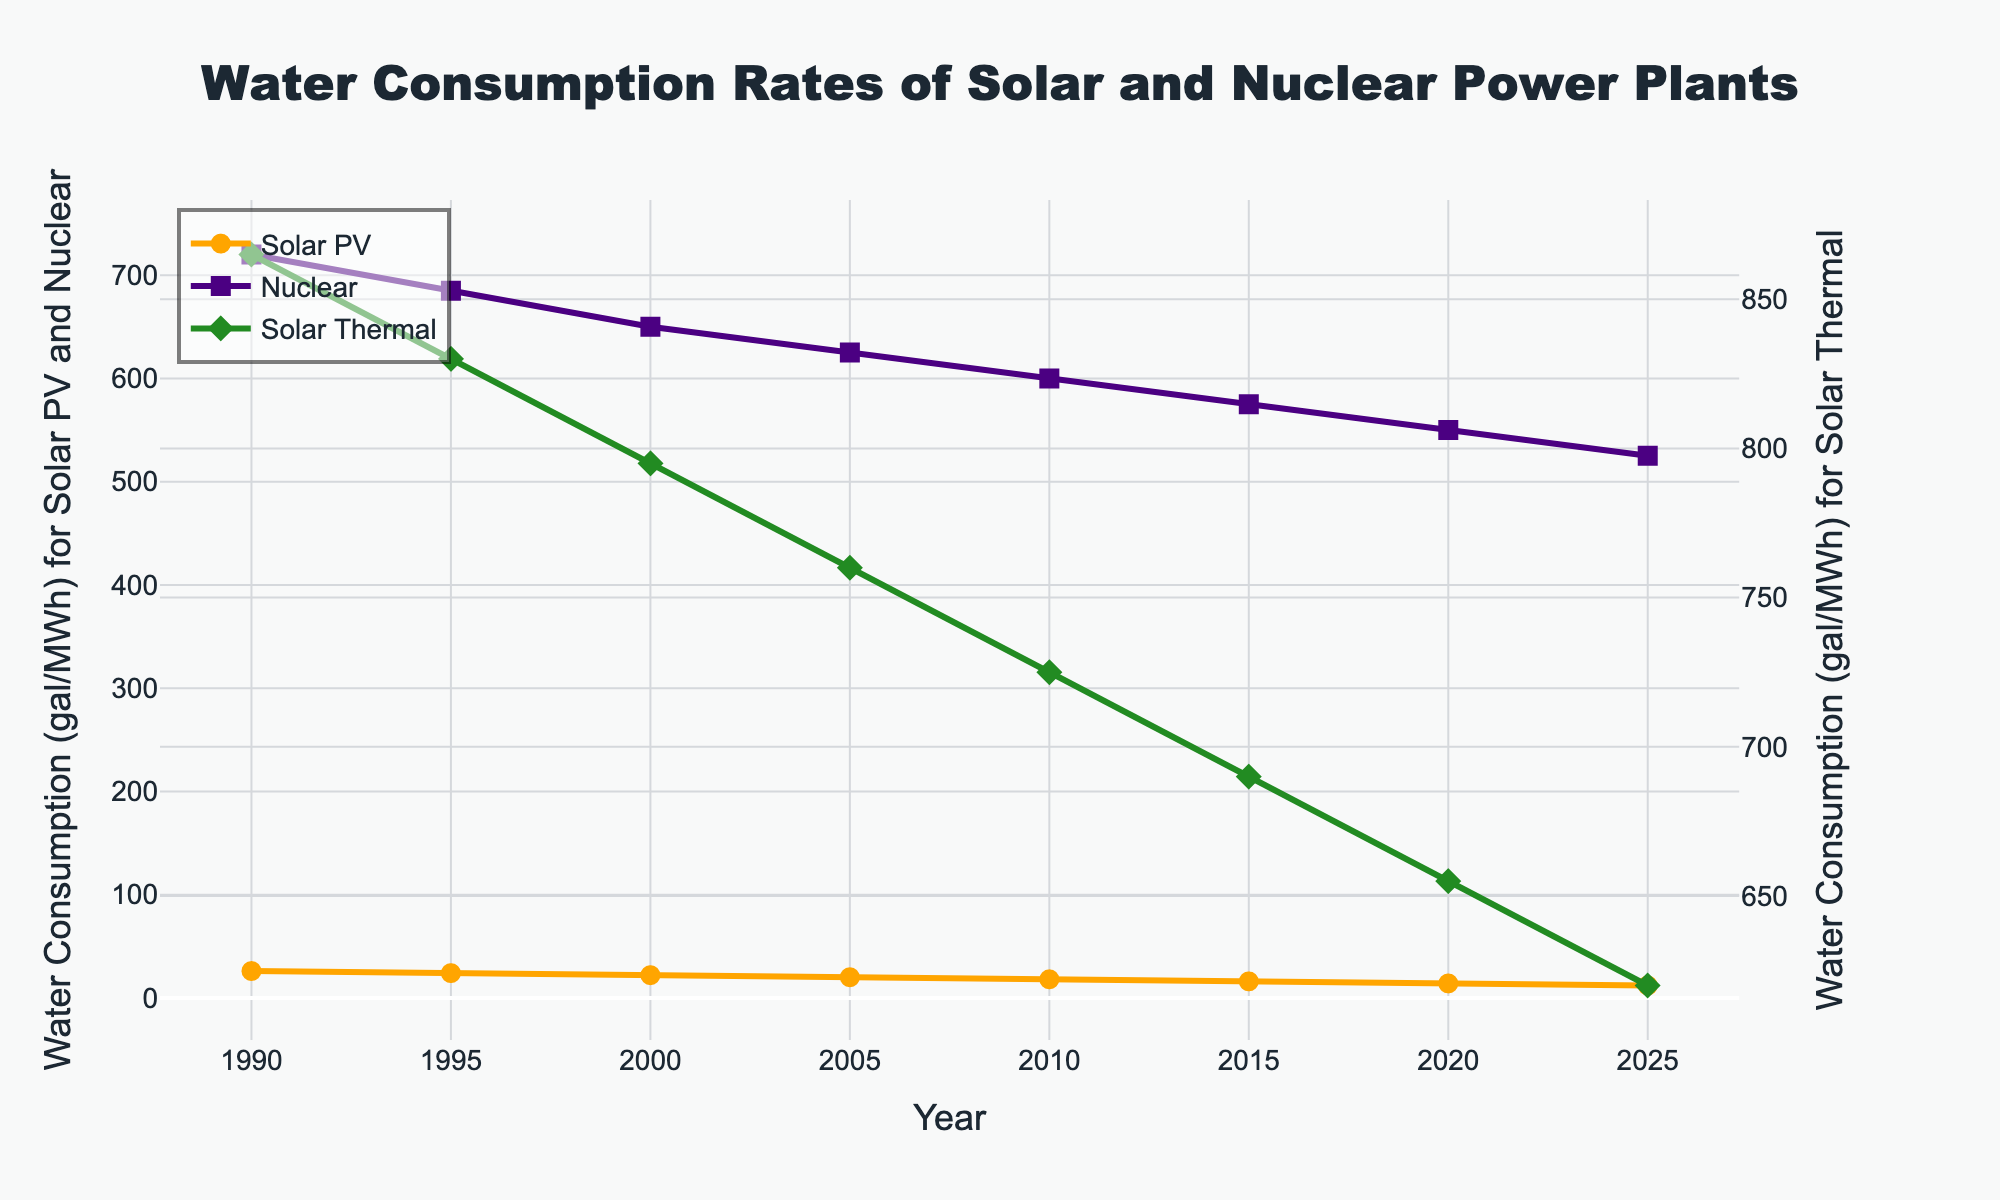What is the trend in water consumption for Solar PV from 1990 to 2025? The trend in water consumption for Solar PV from 1990 to 2025 shows a consistent decrease. In 1990, it started at 26 gal/MWh and continuously decreased to 12 gal/MWh by 2025.
Answer: Decreasing How does the water consumption rate of Nuclear in 2000 compare to Solar PV in 2000? In 2000, the water consumption rate for Nuclear is 650 gal/MWh, while for Solar PV it is 22 gal/MWh. Therefore, Nuclear has a substantially higher water consumption rate compared to Solar PV in 2000.
Answer: Nuclear is much higher than Solar PV What is the average water consumption rate for Solar Thermal over the years shown in the figure? To calculate the average water consumption rate for Solar Thermal, sum up the values (865 + 830 + 795 + 760 + 725 + 690 + 655 + 620) which equals 5940, and then divide by the number of years (8). 5940 / 8 = 742.5 gal/MWh.
Answer: 742.5 gal/MWh At what years do Solar PV and Nuclear have the same decline rates in water consumption? From the figure, the decline rate for Solar PV and Nuclear appears to be constant but not equal. By observing the slope, the rates are different throughout the years; hence, there is no year where they have the same decline rates.
Answer: None In which year does Solar Thermal have the highest water consumption rate? By looking at the green line (Solar Thermal) on the graph, the highest point is in 1990, where it reaches 865 gal/MWh.
Answer: 1990 Between 2000 and 2015, by how much does the water consumption rate for Nuclear change? In 2000, Nuclear's rate is 650 gal/MWh, and in 2015, it is 575 gal/MWh. The change is calculated by subtracting these values: 650 - 575 = 75 gal/MWh.
Answer: 75 gal/MWh How does the water consumption rate for Solar Thermal change from 1990 to 2015? In 1990, the water consumption rate for Solar Thermal is 865 gal/MWh, and by 2015, it drops to 690 gal/MWh. The change can be calculated as 865 - 690 = 175 gal/MWh.
Answer: Decreased by 175 gal/MWh What is the difference in water consumption between Solar PV and Nuclear in 2025? In 2025, the water consumption rate is 12 gal/MWh for Solar PV and 525 gal/MWh for Nuclear. So, the difference is 525 - 12 = 513 gal/MWh.
Answer: 513 gal/MWh Visually, which power source has seen the steepest decline in water consumption rates? By observing the slopes of the lines, Solar PV (represented in orange) seems to have the steepest decline in water consumption rates from 26 gal/MWh in 1990 to 12 gal/MWh in 2025.
Answer: Solar PV During the period from 1990 to 2025, which power source has the least variation in water consumption rates? Solar PV shows the least variation in water consumption, as it steadily decreases from 26 gal/MWh to 12 gal/MWh, compared to the other sources whose initial values are very high and show significant changes.
Answer: Solar PV 